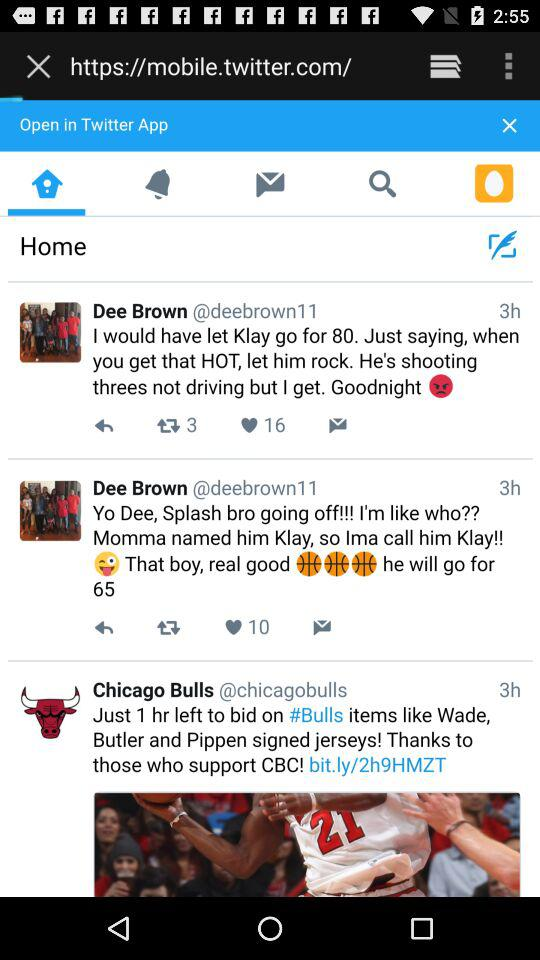What is the number of retweets? The number of retweets is 3. 